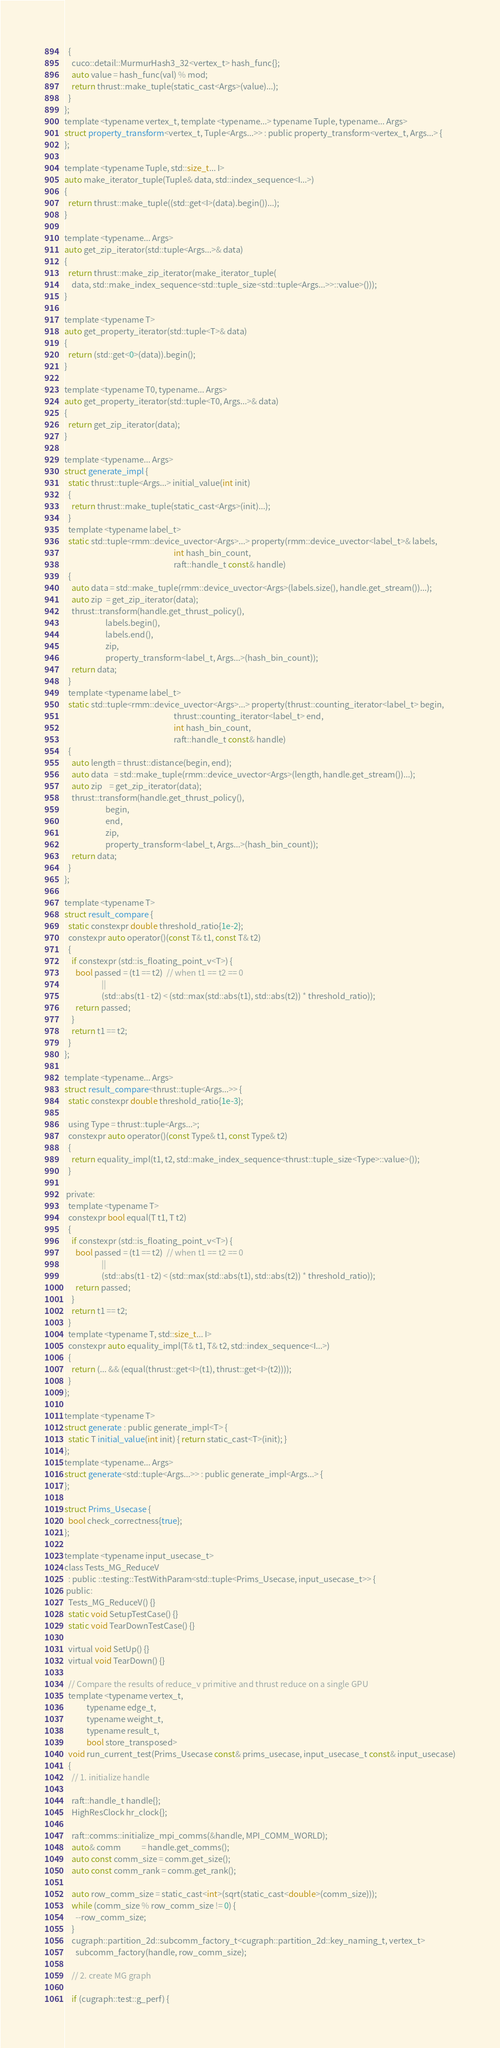Convert code to text. <code><loc_0><loc_0><loc_500><loc_500><_Cuda_>  {
    cuco::detail::MurmurHash3_32<vertex_t> hash_func{};
    auto value = hash_func(val) % mod;
    return thrust::make_tuple(static_cast<Args>(value)...);
  }
};
template <typename vertex_t, template <typename...> typename Tuple, typename... Args>
struct property_transform<vertex_t, Tuple<Args...>> : public property_transform<vertex_t, Args...> {
};

template <typename Tuple, std::size_t... I>
auto make_iterator_tuple(Tuple& data, std::index_sequence<I...>)
{
  return thrust::make_tuple((std::get<I>(data).begin())...);
}

template <typename... Args>
auto get_zip_iterator(std::tuple<Args...>& data)
{
  return thrust::make_zip_iterator(make_iterator_tuple(
    data, std::make_index_sequence<std::tuple_size<std::tuple<Args...>>::value>()));
}

template <typename T>
auto get_property_iterator(std::tuple<T>& data)
{
  return (std::get<0>(data)).begin();
}

template <typename T0, typename... Args>
auto get_property_iterator(std::tuple<T0, Args...>& data)
{
  return get_zip_iterator(data);
}

template <typename... Args>
struct generate_impl {
  static thrust::tuple<Args...> initial_value(int init)
  {
    return thrust::make_tuple(static_cast<Args>(init)...);
  }
  template <typename label_t>
  static std::tuple<rmm::device_uvector<Args>...> property(rmm::device_uvector<label_t>& labels,
                                                           int hash_bin_count,
                                                           raft::handle_t const& handle)
  {
    auto data = std::make_tuple(rmm::device_uvector<Args>(labels.size(), handle.get_stream())...);
    auto zip  = get_zip_iterator(data);
    thrust::transform(handle.get_thrust_policy(),
                      labels.begin(),
                      labels.end(),
                      zip,
                      property_transform<label_t, Args...>(hash_bin_count));
    return data;
  }
  template <typename label_t>
  static std::tuple<rmm::device_uvector<Args>...> property(thrust::counting_iterator<label_t> begin,
                                                           thrust::counting_iterator<label_t> end,
                                                           int hash_bin_count,
                                                           raft::handle_t const& handle)
  {
    auto length = thrust::distance(begin, end);
    auto data   = std::make_tuple(rmm::device_uvector<Args>(length, handle.get_stream())...);
    auto zip    = get_zip_iterator(data);
    thrust::transform(handle.get_thrust_policy(),
                      begin,
                      end,
                      zip,
                      property_transform<label_t, Args...>(hash_bin_count));
    return data;
  }
};

template <typename T>
struct result_compare {
  static constexpr double threshold_ratio{1e-2};
  constexpr auto operator()(const T& t1, const T& t2)
  {
    if constexpr (std::is_floating_point_v<T>) {
      bool passed = (t1 == t2)  // when t1 == t2 == 0
                    ||
                    (std::abs(t1 - t2) < (std::max(std::abs(t1), std::abs(t2)) * threshold_ratio));
      return passed;
    }
    return t1 == t2;
  }
};

template <typename... Args>
struct result_compare<thrust::tuple<Args...>> {
  static constexpr double threshold_ratio{1e-3};

  using Type = thrust::tuple<Args...>;
  constexpr auto operator()(const Type& t1, const Type& t2)
  {
    return equality_impl(t1, t2, std::make_index_sequence<thrust::tuple_size<Type>::value>());
  }

 private:
  template <typename T>
  constexpr bool equal(T t1, T t2)
  {
    if constexpr (std::is_floating_point_v<T>) {
      bool passed = (t1 == t2)  // when t1 == t2 == 0
                    ||
                    (std::abs(t1 - t2) < (std::max(std::abs(t1), std::abs(t2)) * threshold_ratio));
      return passed;
    }
    return t1 == t2;
  }
  template <typename T, std::size_t... I>
  constexpr auto equality_impl(T& t1, T& t2, std::index_sequence<I...>)
  {
    return (... && (equal(thrust::get<I>(t1), thrust::get<I>(t2))));
  }
};

template <typename T>
struct generate : public generate_impl<T> {
  static T initial_value(int init) { return static_cast<T>(init); }
};
template <typename... Args>
struct generate<std::tuple<Args...>> : public generate_impl<Args...> {
};

struct Prims_Usecase {
  bool check_correctness{true};
};

template <typename input_usecase_t>
class Tests_MG_ReduceV
  : public ::testing::TestWithParam<std::tuple<Prims_Usecase, input_usecase_t>> {
 public:
  Tests_MG_ReduceV() {}
  static void SetupTestCase() {}
  static void TearDownTestCase() {}

  virtual void SetUp() {}
  virtual void TearDown() {}

  // Compare the results of reduce_v primitive and thrust reduce on a single GPU
  template <typename vertex_t,
            typename edge_t,
            typename weight_t,
            typename result_t,
            bool store_transposed>
  void run_current_test(Prims_Usecase const& prims_usecase, input_usecase_t const& input_usecase)
  {
    // 1. initialize handle

    raft::handle_t handle{};
    HighResClock hr_clock{};

    raft::comms::initialize_mpi_comms(&handle, MPI_COMM_WORLD);
    auto& comm           = handle.get_comms();
    auto const comm_size = comm.get_size();
    auto const comm_rank = comm.get_rank();

    auto row_comm_size = static_cast<int>(sqrt(static_cast<double>(comm_size)));
    while (comm_size % row_comm_size != 0) {
      --row_comm_size;
    }
    cugraph::partition_2d::subcomm_factory_t<cugraph::partition_2d::key_naming_t, vertex_t>
      subcomm_factory(handle, row_comm_size);

    // 2. create MG graph

    if (cugraph::test::g_perf) {</code> 